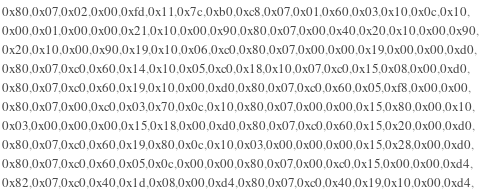Convert code to text. <code><loc_0><loc_0><loc_500><loc_500><_Cuda_>0x80,0x07,0x02,0x00,0xfd,0x11,0x7c,0xb0,0xc8,0x07,0x01,0x60,0x03,0x10,0x0c,0x10,
0x00,0x01,0x00,0x00,0x21,0x10,0x00,0x90,0x80,0x07,0x00,0x40,0x20,0x10,0x00,0x90,
0x20,0x10,0x00,0x90,0x19,0x10,0x06,0xc0,0x80,0x07,0x00,0x00,0x19,0x00,0x00,0xd0,
0x80,0x07,0xc0,0x60,0x14,0x10,0x05,0xc0,0x18,0x10,0x07,0xc0,0x15,0x08,0x00,0xd0,
0x80,0x07,0xc0,0x60,0x19,0x10,0x00,0xd0,0x80,0x07,0xc0,0x60,0x05,0xf8,0x00,0x00,
0x80,0x07,0x00,0xc0,0x03,0x70,0x0c,0x10,0x80,0x07,0x00,0x00,0x15,0x80,0x00,0x10,
0x03,0x00,0x00,0x00,0x15,0x18,0x00,0xd0,0x80,0x07,0xc0,0x60,0x15,0x20,0x00,0xd0,
0x80,0x07,0xc0,0x60,0x19,0x80,0x0c,0x10,0x03,0x00,0x00,0x00,0x15,0x28,0x00,0xd0,
0x80,0x07,0xc0,0x60,0x05,0x0c,0x00,0x00,0x80,0x07,0x00,0xc0,0x15,0x00,0x00,0xd4,
0x82,0x07,0xc0,0x40,0x1d,0x08,0x00,0xd4,0x80,0x07,0xc0,0x40,0x19,0x10,0x00,0xd4,</code> 